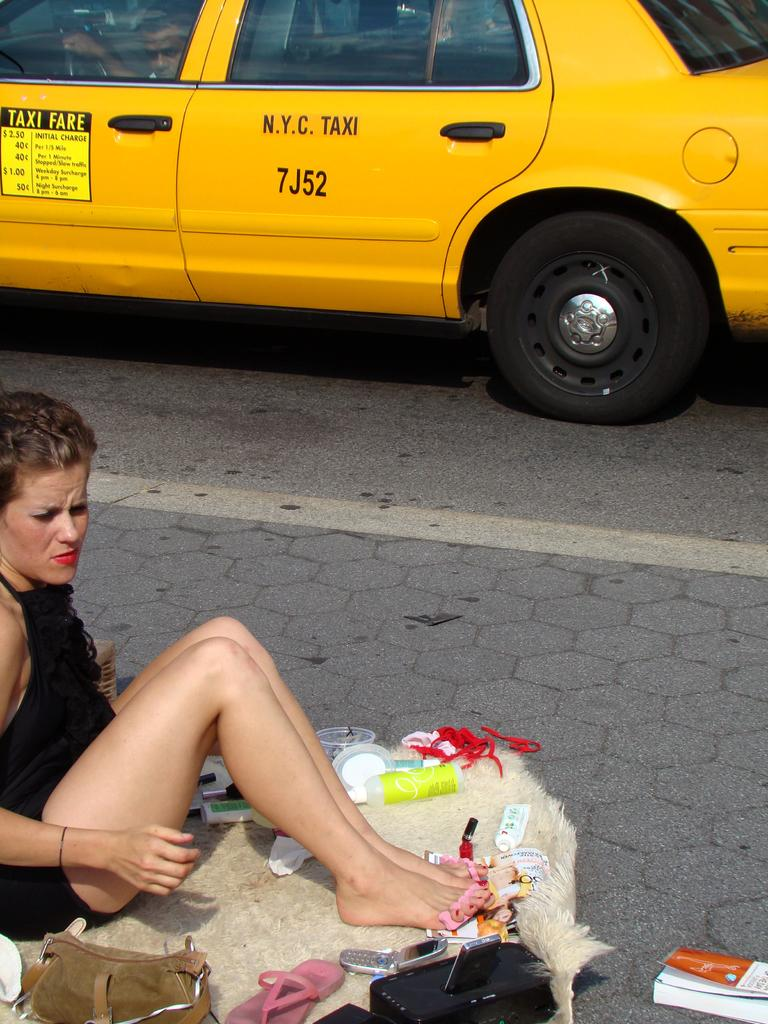<image>
Give a short and clear explanation of the subsequent image. Woman sitting next to a yellow taxi with the call sign 7J52. 